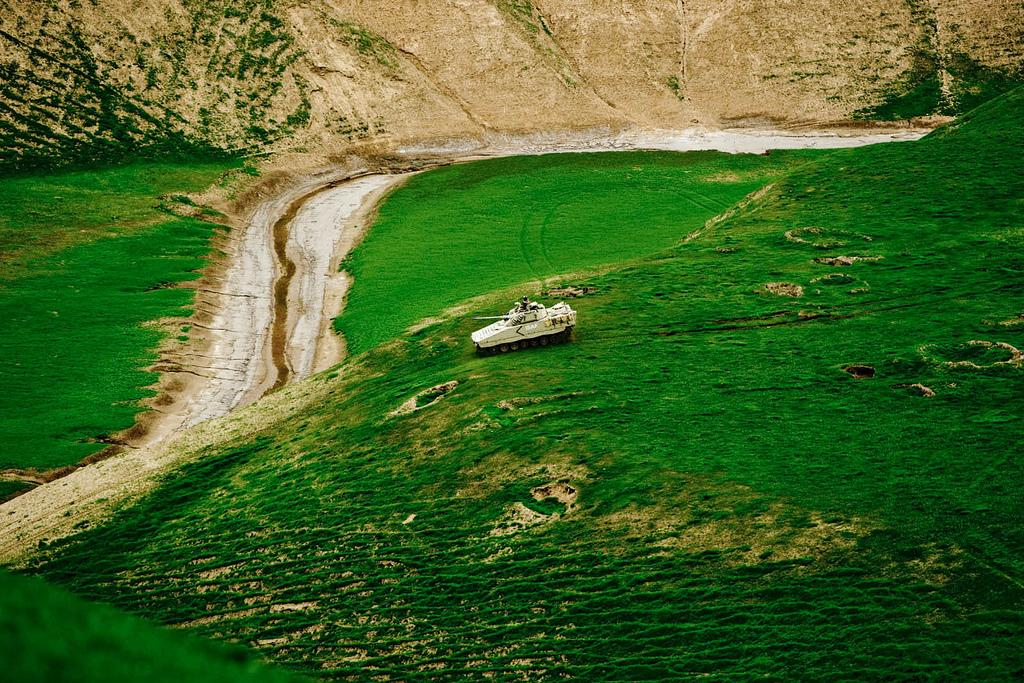What is the main subject of the image? The main subject of the image is an army tank. What is the army tank doing in the image? The army tank is moving in the image. On what surface is the army tank located? The army tank is on the surface of the grass. What can be seen in the background of the image? There are mountains in the background of the image. How many dimes are scattered around the army tank in the image? There are no dimes present in the image; it features an army tank on the grass with mountains in the background. 